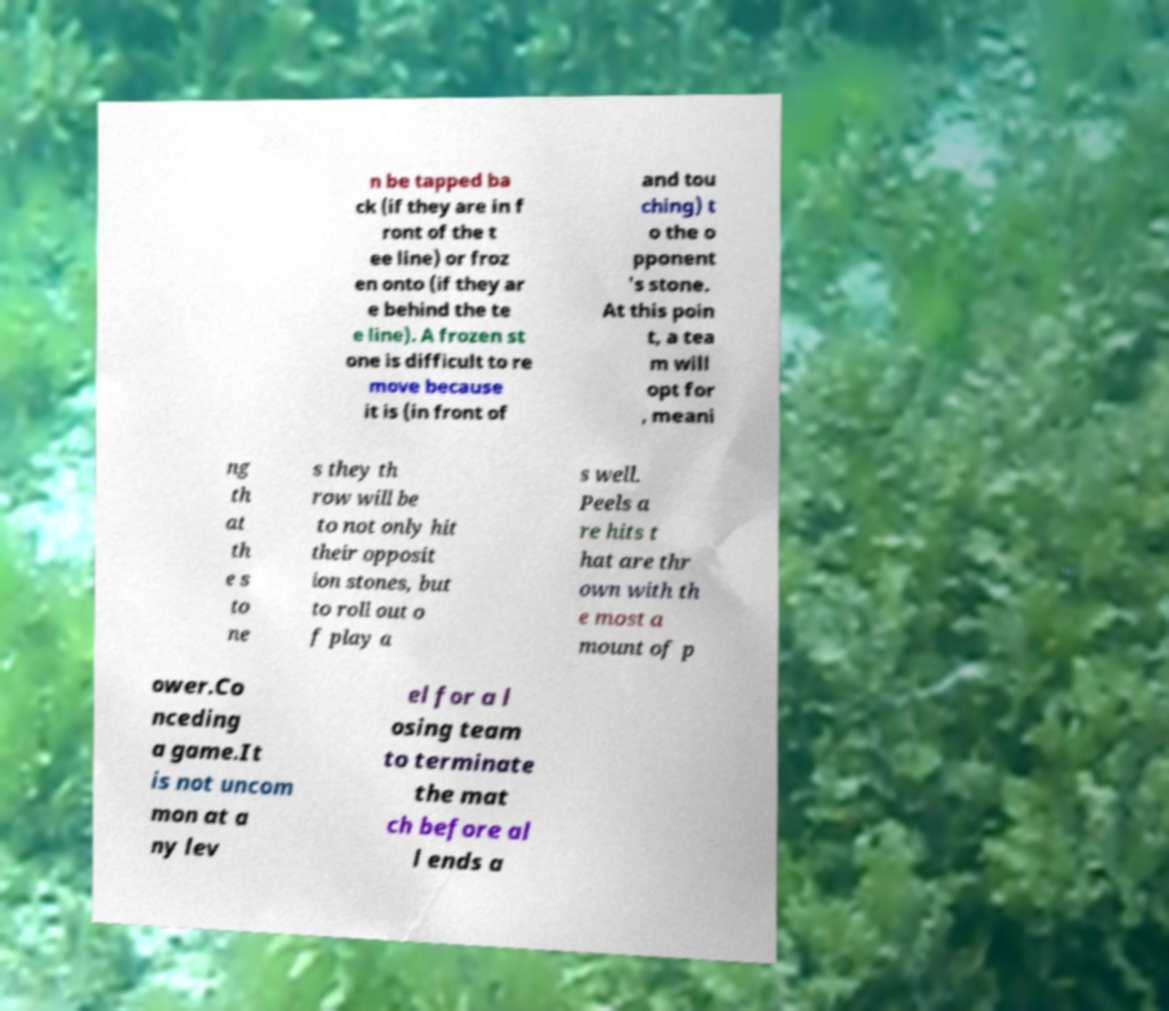Can you accurately transcribe the text from the provided image for me? n be tapped ba ck (if they are in f ront of the t ee line) or froz en onto (if they ar e behind the te e line). A frozen st one is difficult to re move because it is (in front of and tou ching) t o the o pponent 's stone. At this poin t, a tea m will opt for , meani ng th at th e s to ne s they th row will be to not only hit their opposit ion stones, but to roll out o f play a s well. Peels a re hits t hat are thr own with th e most a mount of p ower.Co nceding a game.It is not uncom mon at a ny lev el for a l osing team to terminate the mat ch before al l ends a 